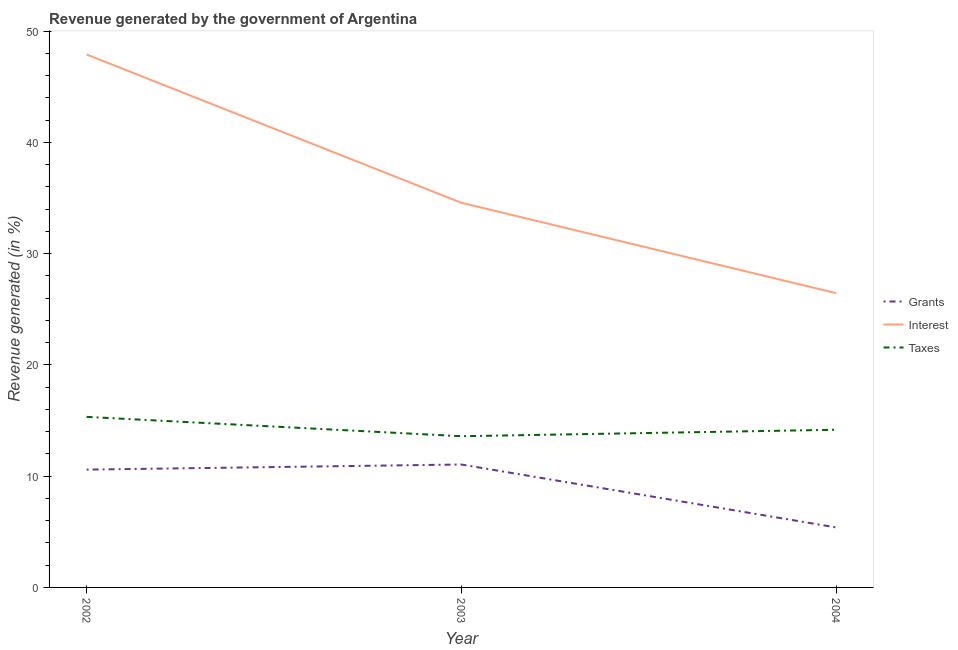Does the line corresponding to percentage of revenue generated by grants intersect with the line corresponding to percentage of revenue generated by interest?
Offer a terse response. No. Is the number of lines equal to the number of legend labels?
Offer a terse response. Yes. What is the percentage of revenue generated by grants in 2002?
Keep it short and to the point. 10.59. Across all years, what is the maximum percentage of revenue generated by grants?
Provide a succinct answer. 11.05. Across all years, what is the minimum percentage of revenue generated by grants?
Provide a short and direct response. 5.39. In which year was the percentage of revenue generated by interest maximum?
Make the answer very short. 2002. What is the total percentage of revenue generated by interest in the graph?
Your answer should be compact. 108.95. What is the difference between the percentage of revenue generated by taxes in 2002 and that in 2004?
Provide a succinct answer. 1.16. What is the difference between the percentage of revenue generated by taxes in 2004 and the percentage of revenue generated by grants in 2003?
Provide a short and direct response. 3.12. What is the average percentage of revenue generated by taxes per year?
Keep it short and to the point. 14.37. In the year 2003, what is the difference between the percentage of revenue generated by interest and percentage of revenue generated by grants?
Offer a terse response. 23.53. In how many years, is the percentage of revenue generated by interest greater than 44 %?
Ensure brevity in your answer.  1. What is the ratio of the percentage of revenue generated by grants in 2002 to that in 2003?
Offer a terse response. 0.96. Is the percentage of revenue generated by interest in 2002 less than that in 2003?
Your response must be concise. No. Is the difference between the percentage of revenue generated by grants in 2003 and 2004 greater than the difference between the percentage of revenue generated by interest in 2003 and 2004?
Keep it short and to the point. No. What is the difference between the highest and the second highest percentage of revenue generated by grants?
Keep it short and to the point. 0.46. What is the difference between the highest and the lowest percentage of revenue generated by taxes?
Offer a very short reply. 1.74. Is the percentage of revenue generated by grants strictly greater than the percentage of revenue generated by interest over the years?
Give a very brief answer. No. Where does the legend appear in the graph?
Your response must be concise. Center right. What is the title of the graph?
Your response must be concise. Revenue generated by the government of Argentina. What is the label or title of the X-axis?
Your answer should be compact. Year. What is the label or title of the Y-axis?
Give a very brief answer. Revenue generated (in %). What is the Revenue generated (in %) in Grants in 2002?
Your response must be concise. 10.59. What is the Revenue generated (in %) of Interest in 2002?
Make the answer very short. 47.91. What is the Revenue generated (in %) of Taxes in 2002?
Your answer should be very brief. 15.33. What is the Revenue generated (in %) in Grants in 2003?
Your response must be concise. 11.05. What is the Revenue generated (in %) of Interest in 2003?
Keep it short and to the point. 34.58. What is the Revenue generated (in %) of Taxes in 2003?
Provide a short and direct response. 13.59. What is the Revenue generated (in %) in Grants in 2004?
Make the answer very short. 5.39. What is the Revenue generated (in %) of Interest in 2004?
Make the answer very short. 26.46. What is the Revenue generated (in %) of Taxes in 2004?
Give a very brief answer. 14.17. Across all years, what is the maximum Revenue generated (in %) of Grants?
Ensure brevity in your answer.  11.05. Across all years, what is the maximum Revenue generated (in %) in Interest?
Your response must be concise. 47.91. Across all years, what is the maximum Revenue generated (in %) in Taxes?
Provide a succinct answer. 15.33. Across all years, what is the minimum Revenue generated (in %) in Grants?
Provide a succinct answer. 5.39. Across all years, what is the minimum Revenue generated (in %) in Interest?
Provide a short and direct response. 26.46. Across all years, what is the minimum Revenue generated (in %) of Taxes?
Offer a terse response. 13.59. What is the total Revenue generated (in %) of Grants in the graph?
Your response must be concise. 27.04. What is the total Revenue generated (in %) in Interest in the graph?
Keep it short and to the point. 108.95. What is the total Revenue generated (in %) in Taxes in the graph?
Make the answer very short. 43.1. What is the difference between the Revenue generated (in %) of Grants in 2002 and that in 2003?
Your response must be concise. -0.46. What is the difference between the Revenue generated (in %) of Interest in 2002 and that in 2003?
Keep it short and to the point. 13.33. What is the difference between the Revenue generated (in %) in Taxes in 2002 and that in 2003?
Your response must be concise. 1.74. What is the difference between the Revenue generated (in %) in Grants in 2002 and that in 2004?
Give a very brief answer. 5.2. What is the difference between the Revenue generated (in %) of Interest in 2002 and that in 2004?
Give a very brief answer. 21.45. What is the difference between the Revenue generated (in %) in Taxes in 2002 and that in 2004?
Ensure brevity in your answer.  1.16. What is the difference between the Revenue generated (in %) in Grants in 2003 and that in 2004?
Keep it short and to the point. 5.66. What is the difference between the Revenue generated (in %) in Interest in 2003 and that in 2004?
Your answer should be compact. 8.12. What is the difference between the Revenue generated (in %) in Taxes in 2003 and that in 2004?
Give a very brief answer. -0.58. What is the difference between the Revenue generated (in %) in Grants in 2002 and the Revenue generated (in %) in Interest in 2003?
Give a very brief answer. -23.99. What is the difference between the Revenue generated (in %) in Grants in 2002 and the Revenue generated (in %) in Taxes in 2003?
Give a very brief answer. -3. What is the difference between the Revenue generated (in %) in Interest in 2002 and the Revenue generated (in %) in Taxes in 2003?
Make the answer very short. 34.32. What is the difference between the Revenue generated (in %) of Grants in 2002 and the Revenue generated (in %) of Interest in 2004?
Keep it short and to the point. -15.87. What is the difference between the Revenue generated (in %) of Grants in 2002 and the Revenue generated (in %) of Taxes in 2004?
Your answer should be very brief. -3.58. What is the difference between the Revenue generated (in %) in Interest in 2002 and the Revenue generated (in %) in Taxes in 2004?
Your response must be concise. 33.74. What is the difference between the Revenue generated (in %) in Grants in 2003 and the Revenue generated (in %) in Interest in 2004?
Keep it short and to the point. -15.41. What is the difference between the Revenue generated (in %) of Grants in 2003 and the Revenue generated (in %) of Taxes in 2004?
Offer a terse response. -3.12. What is the difference between the Revenue generated (in %) in Interest in 2003 and the Revenue generated (in %) in Taxes in 2004?
Ensure brevity in your answer.  20.41. What is the average Revenue generated (in %) in Grants per year?
Ensure brevity in your answer.  9.01. What is the average Revenue generated (in %) of Interest per year?
Your response must be concise. 36.32. What is the average Revenue generated (in %) in Taxes per year?
Provide a short and direct response. 14.37. In the year 2002, what is the difference between the Revenue generated (in %) of Grants and Revenue generated (in %) of Interest?
Provide a short and direct response. -37.32. In the year 2002, what is the difference between the Revenue generated (in %) in Grants and Revenue generated (in %) in Taxes?
Make the answer very short. -4.74. In the year 2002, what is the difference between the Revenue generated (in %) of Interest and Revenue generated (in %) of Taxes?
Provide a succinct answer. 32.58. In the year 2003, what is the difference between the Revenue generated (in %) in Grants and Revenue generated (in %) in Interest?
Your answer should be compact. -23.53. In the year 2003, what is the difference between the Revenue generated (in %) in Grants and Revenue generated (in %) in Taxes?
Ensure brevity in your answer.  -2.54. In the year 2003, what is the difference between the Revenue generated (in %) of Interest and Revenue generated (in %) of Taxes?
Your response must be concise. 20.99. In the year 2004, what is the difference between the Revenue generated (in %) in Grants and Revenue generated (in %) in Interest?
Ensure brevity in your answer.  -21.06. In the year 2004, what is the difference between the Revenue generated (in %) in Grants and Revenue generated (in %) in Taxes?
Keep it short and to the point. -8.78. In the year 2004, what is the difference between the Revenue generated (in %) of Interest and Revenue generated (in %) of Taxes?
Give a very brief answer. 12.28. What is the ratio of the Revenue generated (in %) of Grants in 2002 to that in 2003?
Make the answer very short. 0.96. What is the ratio of the Revenue generated (in %) of Interest in 2002 to that in 2003?
Your answer should be very brief. 1.39. What is the ratio of the Revenue generated (in %) in Taxes in 2002 to that in 2003?
Offer a very short reply. 1.13. What is the ratio of the Revenue generated (in %) in Grants in 2002 to that in 2004?
Keep it short and to the point. 1.96. What is the ratio of the Revenue generated (in %) of Interest in 2002 to that in 2004?
Provide a short and direct response. 1.81. What is the ratio of the Revenue generated (in %) in Taxes in 2002 to that in 2004?
Keep it short and to the point. 1.08. What is the ratio of the Revenue generated (in %) of Grants in 2003 to that in 2004?
Your response must be concise. 2.05. What is the ratio of the Revenue generated (in %) in Interest in 2003 to that in 2004?
Make the answer very short. 1.31. What is the ratio of the Revenue generated (in %) in Taxes in 2003 to that in 2004?
Offer a terse response. 0.96. What is the difference between the highest and the second highest Revenue generated (in %) of Grants?
Provide a short and direct response. 0.46. What is the difference between the highest and the second highest Revenue generated (in %) of Interest?
Ensure brevity in your answer.  13.33. What is the difference between the highest and the second highest Revenue generated (in %) of Taxes?
Provide a succinct answer. 1.16. What is the difference between the highest and the lowest Revenue generated (in %) in Grants?
Your response must be concise. 5.66. What is the difference between the highest and the lowest Revenue generated (in %) of Interest?
Provide a succinct answer. 21.45. What is the difference between the highest and the lowest Revenue generated (in %) in Taxes?
Provide a short and direct response. 1.74. 